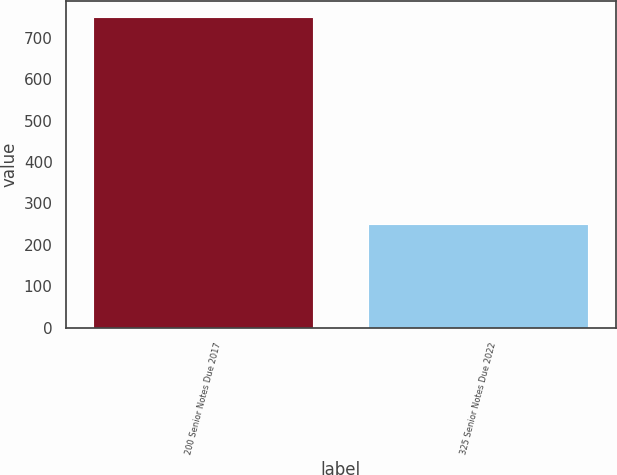<chart> <loc_0><loc_0><loc_500><loc_500><bar_chart><fcel>200 Senior Notes Due 2017<fcel>325 Senior Notes Due 2022<nl><fcel>750<fcel>250<nl></chart> 